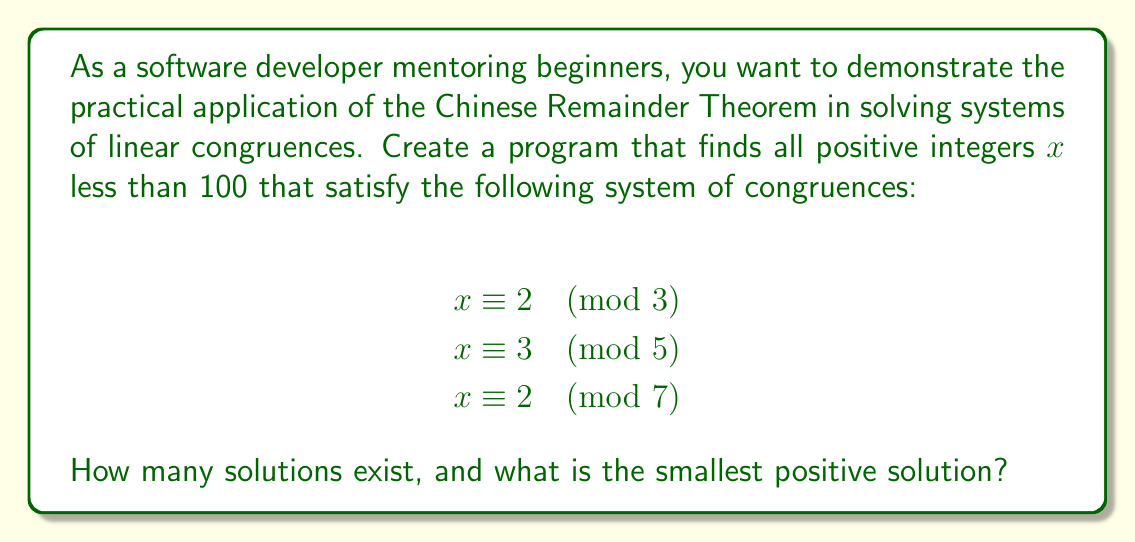Solve this math problem. To solve this problem using the Chinese Remainder Theorem (CRT), we'll follow these steps:

1) First, we need to calculate the product of all moduli:
   $M = 3 \times 5 \times 7 = 105$

2) For each congruence, we calculate $M_i = M / m_i$:
   $M_1 = 105 / 3 = 35$
   $M_2 = 105 / 5 = 21$
   $M_3 = 105 / 7 = 15$

3) We need to find the modular multiplicative inverses of each $M_i$ modulo $m_i$:
   $35^{-1} \equiv 2 \pmod{3}$
   $21^{-1} \equiv 1 \pmod{5}$
   $15^{-1} \equiv 1 \pmod{7}$

4) Now we can calculate the solution:
   $x \equiv (2 \times 35 \times 2 + 3 \times 21 \times 1 + 2 \times 15 \times 1) \pmod{105}$
   $x \equiv (140 + 63 + 30) \pmod{105}$
   $x \equiv 233 \pmod{105}$
   $x \equiv 23 \pmod{105}$

5) The general solution is $x = 23 + 105k$, where $k$ is any integer.

6) To find all solutions less than 100:
   $23 < 100$
   $23 + 105 = 128 > 100$

   So there is only one solution less than 100.

From a programming perspective, we could implement this solution using modular arithmetic operations and a loop to check all values less than 100. This demonstrates how number theory concepts can be applied in practical programming scenarios.
Answer: There is 1 solution less than 100, and the smallest positive solution is 23. 